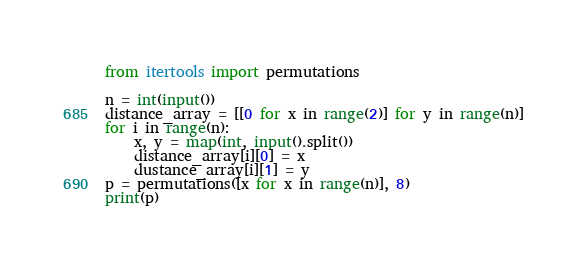Convert code to text. <code><loc_0><loc_0><loc_500><loc_500><_Python_>from itertools import permutations

n = int(input())
distance_array = [[0 for x in range(2)] for y in range(n)]
for i in range(n):
    x, y = map(int, input().split())
    distance_array[i][0] = x
    dustance_array[i][1] = y
p = permutations([x for x in range(n)], 8)
print(p)
                  </code> 